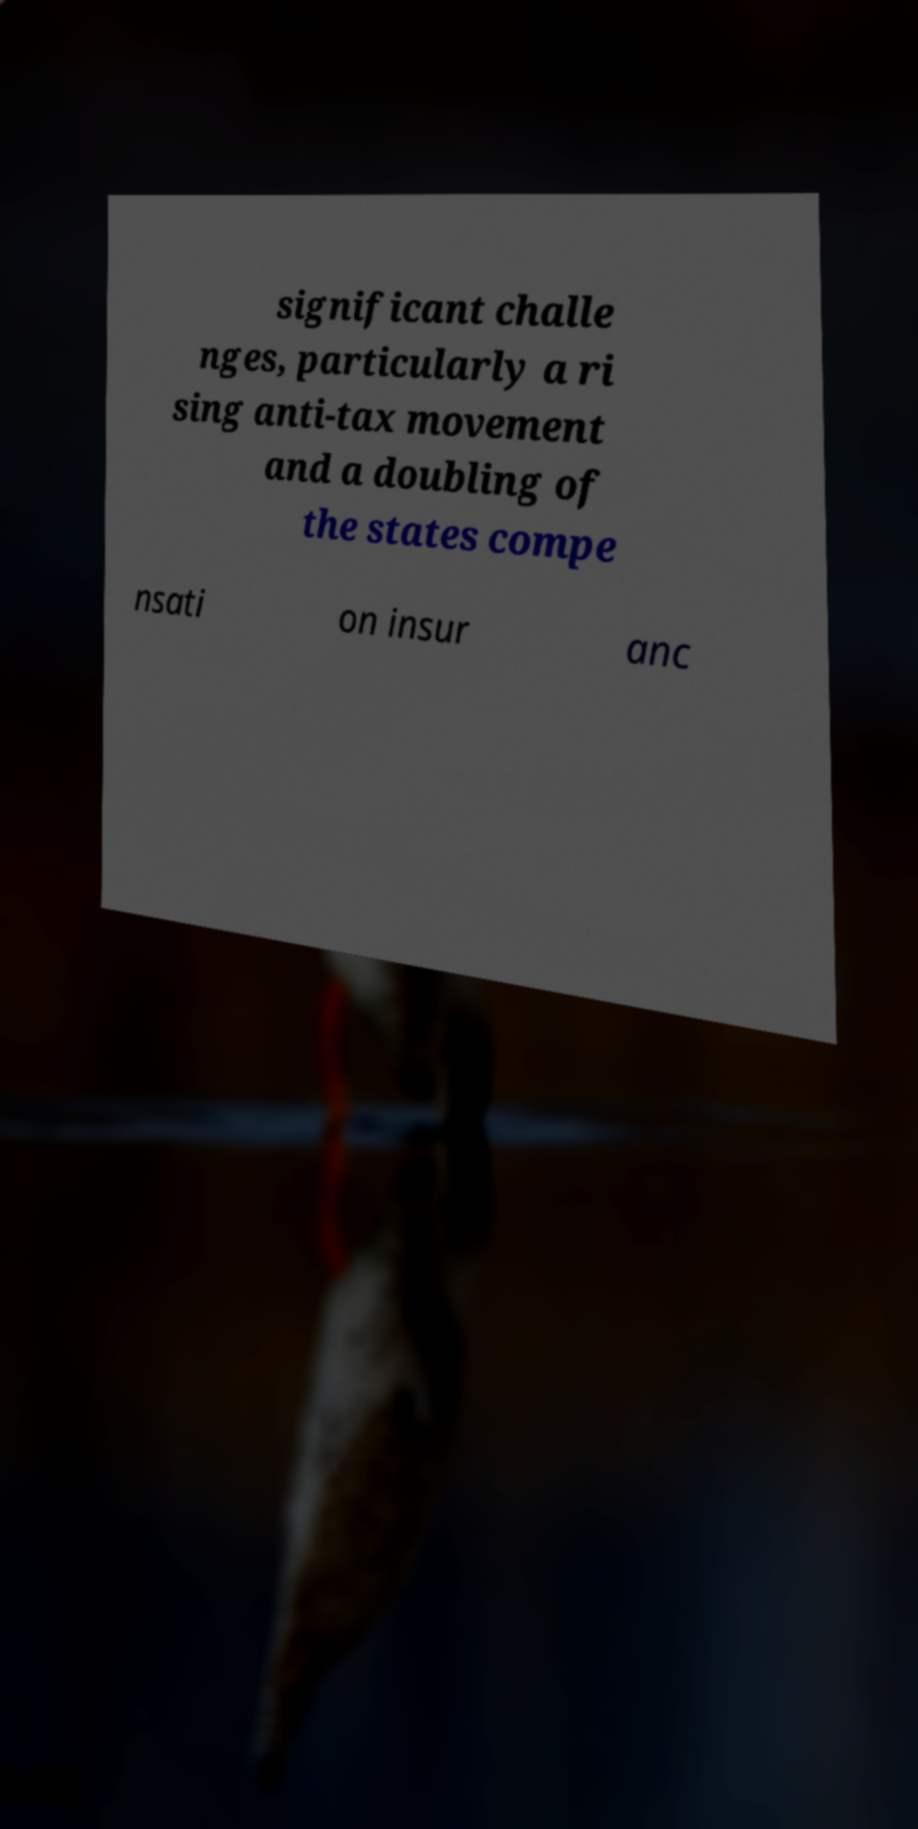Can you read and provide the text displayed in the image?This photo seems to have some interesting text. Can you extract and type it out for me? significant challe nges, particularly a ri sing anti-tax movement and a doubling of the states compe nsati on insur anc 